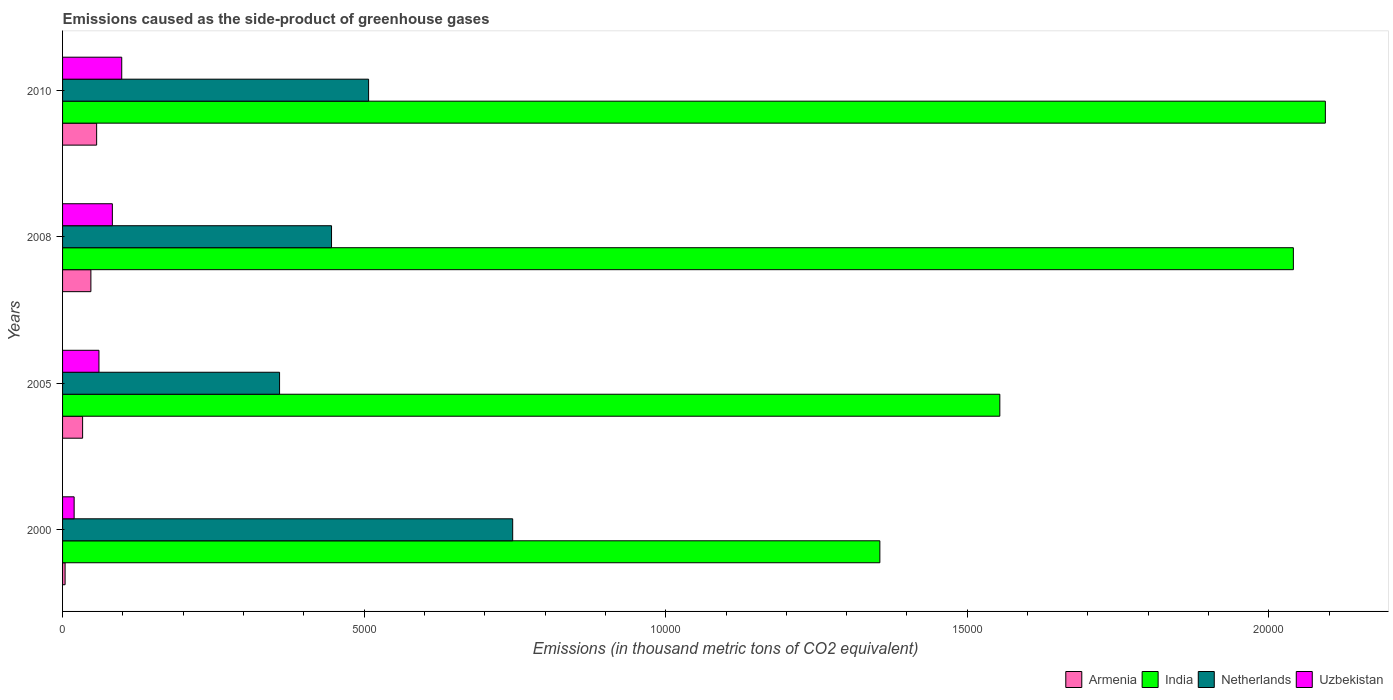How many groups of bars are there?
Make the answer very short. 4. Are the number of bars per tick equal to the number of legend labels?
Provide a short and direct response. Yes. Are the number of bars on each tick of the Y-axis equal?
Your answer should be very brief. Yes. How many bars are there on the 4th tick from the top?
Provide a short and direct response. 4. How many bars are there on the 4th tick from the bottom?
Provide a short and direct response. 4. What is the label of the 4th group of bars from the top?
Provide a short and direct response. 2000. What is the emissions caused as the side-product of greenhouse gases in Uzbekistan in 2000?
Your answer should be very brief. 192. Across all years, what is the maximum emissions caused as the side-product of greenhouse gases in Netherlands?
Your answer should be very brief. 7462.9. Across all years, what is the minimum emissions caused as the side-product of greenhouse gases in Armenia?
Your response must be concise. 42. What is the total emissions caused as the side-product of greenhouse gases in Uzbekistan in the graph?
Provide a succinct answer. 2601.8. What is the difference between the emissions caused as the side-product of greenhouse gases in Armenia in 2008 and that in 2010?
Ensure brevity in your answer.  -95.4. What is the difference between the emissions caused as the side-product of greenhouse gases in India in 2010 and the emissions caused as the side-product of greenhouse gases in Armenia in 2005?
Your answer should be compact. 2.06e+04. What is the average emissions caused as the side-product of greenhouse gases in Netherlands per year?
Make the answer very short. 5148.52. In the year 2010, what is the difference between the emissions caused as the side-product of greenhouse gases in Armenia and emissions caused as the side-product of greenhouse gases in Uzbekistan?
Your answer should be very brief. -416. In how many years, is the emissions caused as the side-product of greenhouse gases in India greater than 1000 thousand metric tons?
Keep it short and to the point. 4. What is the ratio of the emissions caused as the side-product of greenhouse gases in Armenia in 2000 to that in 2008?
Keep it short and to the point. 0.09. Is the emissions caused as the side-product of greenhouse gases in Armenia in 2000 less than that in 2008?
Keep it short and to the point. Yes. What is the difference between the highest and the second highest emissions caused as the side-product of greenhouse gases in Armenia?
Give a very brief answer. 95.4. What is the difference between the highest and the lowest emissions caused as the side-product of greenhouse gases in Netherlands?
Provide a succinct answer. 3865.1. In how many years, is the emissions caused as the side-product of greenhouse gases in Armenia greater than the average emissions caused as the side-product of greenhouse gases in Armenia taken over all years?
Your answer should be compact. 2. Is the sum of the emissions caused as the side-product of greenhouse gases in Netherlands in 2000 and 2010 greater than the maximum emissions caused as the side-product of greenhouse gases in India across all years?
Make the answer very short. No. What does the 1st bar from the bottom in 2000 represents?
Provide a short and direct response. Armenia. How many bars are there?
Ensure brevity in your answer.  16. What is the difference between two consecutive major ticks on the X-axis?
Your answer should be very brief. 5000. Are the values on the major ticks of X-axis written in scientific E-notation?
Provide a succinct answer. No. Does the graph contain any zero values?
Make the answer very short. No. Does the graph contain grids?
Offer a very short reply. No. Where does the legend appear in the graph?
Give a very brief answer. Bottom right. How are the legend labels stacked?
Provide a succinct answer. Horizontal. What is the title of the graph?
Give a very brief answer. Emissions caused as the side-product of greenhouse gases. What is the label or title of the X-axis?
Offer a very short reply. Emissions (in thousand metric tons of CO2 equivalent). What is the label or title of the Y-axis?
Your answer should be very brief. Years. What is the Emissions (in thousand metric tons of CO2 equivalent) of Armenia in 2000?
Keep it short and to the point. 42. What is the Emissions (in thousand metric tons of CO2 equivalent) of India in 2000?
Offer a terse response. 1.36e+04. What is the Emissions (in thousand metric tons of CO2 equivalent) in Netherlands in 2000?
Your answer should be very brief. 7462.9. What is the Emissions (in thousand metric tons of CO2 equivalent) in Uzbekistan in 2000?
Your answer should be very brief. 192. What is the Emissions (in thousand metric tons of CO2 equivalent) in Armenia in 2005?
Ensure brevity in your answer.  332.2. What is the Emissions (in thousand metric tons of CO2 equivalent) of India in 2005?
Offer a terse response. 1.55e+04. What is the Emissions (in thousand metric tons of CO2 equivalent) of Netherlands in 2005?
Your response must be concise. 3597.8. What is the Emissions (in thousand metric tons of CO2 equivalent) of Uzbekistan in 2005?
Your answer should be compact. 603.2. What is the Emissions (in thousand metric tons of CO2 equivalent) of Armenia in 2008?
Give a very brief answer. 469.6. What is the Emissions (in thousand metric tons of CO2 equivalent) of India in 2008?
Give a very brief answer. 2.04e+04. What is the Emissions (in thousand metric tons of CO2 equivalent) in Netherlands in 2008?
Your answer should be compact. 4459.4. What is the Emissions (in thousand metric tons of CO2 equivalent) in Uzbekistan in 2008?
Give a very brief answer. 825.6. What is the Emissions (in thousand metric tons of CO2 equivalent) in Armenia in 2010?
Keep it short and to the point. 565. What is the Emissions (in thousand metric tons of CO2 equivalent) in India in 2010?
Offer a terse response. 2.09e+04. What is the Emissions (in thousand metric tons of CO2 equivalent) in Netherlands in 2010?
Keep it short and to the point. 5074. What is the Emissions (in thousand metric tons of CO2 equivalent) in Uzbekistan in 2010?
Give a very brief answer. 981. Across all years, what is the maximum Emissions (in thousand metric tons of CO2 equivalent) of Armenia?
Your response must be concise. 565. Across all years, what is the maximum Emissions (in thousand metric tons of CO2 equivalent) in India?
Your answer should be very brief. 2.09e+04. Across all years, what is the maximum Emissions (in thousand metric tons of CO2 equivalent) of Netherlands?
Provide a succinct answer. 7462.9. Across all years, what is the maximum Emissions (in thousand metric tons of CO2 equivalent) in Uzbekistan?
Your answer should be compact. 981. Across all years, what is the minimum Emissions (in thousand metric tons of CO2 equivalent) of India?
Ensure brevity in your answer.  1.36e+04. Across all years, what is the minimum Emissions (in thousand metric tons of CO2 equivalent) of Netherlands?
Keep it short and to the point. 3597.8. Across all years, what is the minimum Emissions (in thousand metric tons of CO2 equivalent) in Uzbekistan?
Ensure brevity in your answer.  192. What is the total Emissions (in thousand metric tons of CO2 equivalent) in Armenia in the graph?
Offer a terse response. 1408.8. What is the total Emissions (in thousand metric tons of CO2 equivalent) in India in the graph?
Ensure brevity in your answer.  7.04e+04. What is the total Emissions (in thousand metric tons of CO2 equivalent) in Netherlands in the graph?
Make the answer very short. 2.06e+04. What is the total Emissions (in thousand metric tons of CO2 equivalent) of Uzbekistan in the graph?
Provide a succinct answer. 2601.8. What is the difference between the Emissions (in thousand metric tons of CO2 equivalent) in Armenia in 2000 and that in 2005?
Your response must be concise. -290.2. What is the difference between the Emissions (in thousand metric tons of CO2 equivalent) in India in 2000 and that in 2005?
Your answer should be compact. -1989. What is the difference between the Emissions (in thousand metric tons of CO2 equivalent) of Netherlands in 2000 and that in 2005?
Your response must be concise. 3865.1. What is the difference between the Emissions (in thousand metric tons of CO2 equivalent) in Uzbekistan in 2000 and that in 2005?
Keep it short and to the point. -411.2. What is the difference between the Emissions (in thousand metric tons of CO2 equivalent) in Armenia in 2000 and that in 2008?
Offer a very short reply. -427.6. What is the difference between the Emissions (in thousand metric tons of CO2 equivalent) of India in 2000 and that in 2008?
Offer a very short reply. -6856.2. What is the difference between the Emissions (in thousand metric tons of CO2 equivalent) of Netherlands in 2000 and that in 2008?
Your response must be concise. 3003.5. What is the difference between the Emissions (in thousand metric tons of CO2 equivalent) of Uzbekistan in 2000 and that in 2008?
Your response must be concise. -633.6. What is the difference between the Emissions (in thousand metric tons of CO2 equivalent) in Armenia in 2000 and that in 2010?
Keep it short and to the point. -523. What is the difference between the Emissions (in thousand metric tons of CO2 equivalent) of India in 2000 and that in 2010?
Make the answer very short. -7386.3. What is the difference between the Emissions (in thousand metric tons of CO2 equivalent) of Netherlands in 2000 and that in 2010?
Your response must be concise. 2388.9. What is the difference between the Emissions (in thousand metric tons of CO2 equivalent) of Uzbekistan in 2000 and that in 2010?
Your answer should be compact. -789. What is the difference between the Emissions (in thousand metric tons of CO2 equivalent) of Armenia in 2005 and that in 2008?
Provide a short and direct response. -137.4. What is the difference between the Emissions (in thousand metric tons of CO2 equivalent) in India in 2005 and that in 2008?
Your response must be concise. -4867.2. What is the difference between the Emissions (in thousand metric tons of CO2 equivalent) in Netherlands in 2005 and that in 2008?
Your answer should be very brief. -861.6. What is the difference between the Emissions (in thousand metric tons of CO2 equivalent) in Uzbekistan in 2005 and that in 2008?
Make the answer very short. -222.4. What is the difference between the Emissions (in thousand metric tons of CO2 equivalent) in Armenia in 2005 and that in 2010?
Provide a short and direct response. -232.8. What is the difference between the Emissions (in thousand metric tons of CO2 equivalent) of India in 2005 and that in 2010?
Give a very brief answer. -5397.3. What is the difference between the Emissions (in thousand metric tons of CO2 equivalent) of Netherlands in 2005 and that in 2010?
Provide a short and direct response. -1476.2. What is the difference between the Emissions (in thousand metric tons of CO2 equivalent) of Uzbekistan in 2005 and that in 2010?
Your answer should be compact. -377.8. What is the difference between the Emissions (in thousand metric tons of CO2 equivalent) in Armenia in 2008 and that in 2010?
Provide a short and direct response. -95.4. What is the difference between the Emissions (in thousand metric tons of CO2 equivalent) of India in 2008 and that in 2010?
Your answer should be compact. -530.1. What is the difference between the Emissions (in thousand metric tons of CO2 equivalent) in Netherlands in 2008 and that in 2010?
Give a very brief answer. -614.6. What is the difference between the Emissions (in thousand metric tons of CO2 equivalent) of Uzbekistan in 2008 and that in 2010?
Ensure brevity in your answer.  -155.4. What is the difference between the Emissions (in thousand metric tons of CO2 equivalent) of Armenia in 2000 and the Emissions (in thousand metric tons of CO2 equivalent) of India in 2005?
Ensure brevity in your answer.  -1.55e+04. What is the difference between the Emissions (in thousand metric tons of CO2 equivalent) in Armenia in 2000 and the Emissions (in thousand metric tons of CO2 equivalent) in Netherlands in 2005?
Offer a terse response. -3555.8. What is the difference between the Emissions (in thousand metric tons of CO2 equivalent) in Armenia in 2000 and the Emissions (in thousand metric tons of CO2 equivalent) in Uzbekistan in 2005?
Give a very brief answer. -561.2. What is the difference between the Emissions (in thousand metric tons of CO2 equivalent) in India in 2000 and the Emissions (in thousand metric tons of CO2 equivalent) in Netherlands in 2005?
Your answer should be very brief. 9952.9. What is the difference between the Emissions (in thousand metric tons of CO2 equivalent) in India in 2000 and the Emissions (in thousand metric tons of CO2 equivalent) in Uzbekistan in 2005?
Your answer should be very brief. 1.29e+04. What is the difference between the Emissions (in thousand metric tons of CO2 equivalent) in Netherlands in 2000 and the Emissions (in thousand metric tons of CO2 equivalent) in Uzbekistan in 2005?
Ensure brevity in your answer.  6859.7. What is the difference between the Emissions (in thousand metric tons of CO2 equivalent) in Armenia in 2000 and the Emissions (in thousand metric tons of CO2 equivalent) in India in 2008?
Provide a succinct answer. -2.04e+04. What is the difference between the Emissions (in thousand metric tons of CO2 equivalent) in Armenia in 2000 and the Emissions (in thousand metric tons of CO2 equivalent) in Netherlands in 2008?
Provide a short and direct response. -4417.4. What is the difference between the Emissions (in thousand metric tons of CO2 equivalent) in Armenia in 2000 and the Emissions (in thousand metric tons of CO2 equivalent) in Uzbekistan in 2008?
Give a very brief answer. -783.6. What is the difference between the Emissions (in thousand metric tons of CO2 equivalent) of India in 2000 and the Emissions (in thousand metric tons of CO2 equivalent) of Netherlands in 2008?
Your response must be concise. 9091.3. What is the difference between the Emissions (in thousand metric tons of CO2 equivalent) in India in 2000 and the Emissions (in thousand metric tons of CO2 equivalent) in Uzbekistan in 2008?
Offer a terse response. 1.27e+04. What is the difference between the Emissions (in thousand metric tons of CO2 equivalent) in Netherlands in 2000 and the Emissions (in thousand metric tons of CO2 equivalent) in Uzbekistan in 2008?
Offer a very short reply. 6637.3. What is the difference between the Emissions (in thousand metric tons of CO2 equivalent) of Armenia in 2000 and the Emissions (in thousand metric tons of CO2 equivalent) of India in 2010?
Offer a very short reply. -2.09e+04. What is the difference between the Emissions (in thousand metric tons of CO2 equivalent) in Armenia in 2000 and the Emissions (in thousand metric tons of CO2 equivalent) in Netherlands in 2010?
Your response must be concise. -5032. What is the difference between the Emissions (in thousand metric tons of CO2 equivalent) of Armenia in 2000 and the Emissions (in thousand metric tons of CO2 equivalent) of Uzbekistan in 2010?
Keep it short and to the point. -939. What is the difference between the Emissions (in thousand metric tons of CO2 equivalent) in India in 2000 and the Emissions (in thousand metric tons of CO2 equivalent) in Netherlands in 2010?
Provide a succinct answer. 8476.7. What is the difference between the Emissions (in thousand metric tons of CO2 equivalent) of India in 2000 and the Emissions (in thousand metric tons of CO2 equivalent) of Uzbekistan in 2010?
Ensure brevity in your answer.  1.26e+04. What is the difference between the Emissions (in thousand metric tons of CO2 equivalent) of Netherlands in 2000 and the Emissions (in thousand metric tons of CO2 equivalent) of Uzbekistan in 2010?
Offer a terse response. 6481.9. What is the difference between the Emissions (in thousand metric tons of CO2 equivalent) of Armenia in 2005 and the Emissions (in thousand metric tons of CO2 equivalent) of India in 2008?
Give a very brief answer. -2.01e+04. What is the difference between the Emissions (in thousand metric tons of CO2 equivalent) of Armenia in 2005 and the Emissions (in thousand metric tons of CO2 equivalent) of Netherlands in 2008?
Give a very brief answer. -4127.2. What is the difference between the Emissions (in thousand metric tons of CO2 equivalent) of Armenia in 2005 and the Emissions (in thousand metric tons of CO2 equivalent) of Uzbekistan in 2008?
Provide a succinct answer. -493.4. What is the difference between the Emissions (in thousand metric tons of CO2 equivalent) in India in 2005 and the Emissions (in thousand metric tons of CO2 equivalent) in Netherlands in 2008?
Your answer should be very brief. 1.11e+04. What is the difference between the Emissions (in thousand metric tons of CO2 equivalent) in India in 2005 and the Emissions (in thousand metric tons of CO2 equivalent) in Uzbekistan in 2008?
Keep it short and to the point. 1.47e+04. What is the difference between the Emissions (in thousand metric tons of CO2 equivalent) in Netherlands in 2005 and the Emissions (in thousand metric tons of CO2 equivalent) in Uzbekistan in 2008?
Provide a short and direct response. 2772.2. What is the difference between the Emissions (in thousand metric tons of CO2 equivalent) in Armenia in 2005 and the Emissions (in thousand metric tons of CO2 equivalent) in India in 2010?
Give a very brief answer. -2.06e+04. What is the difference between the Emissions (in thousand metric tons of CO2 equivalent) of Armenia in 2005 and the Emissions (in thousand metric tons of CO2 equivalent) of Netherlands in 2010?
Ensure brevity in your answer.  -4741.8. What is the difference between the Emissions (in thousand metric tons of CO2 equivalent) in Armenia in 2005 and the Emissions (in thousand metric tons of CO2 equivalent) in Uzbekistan in 2010?
Keep it short and to the point. -648.8. What is the difference between the Emissions (in thousand metric tons of CO2 equivalent) in India in 2005 and the Emissions (in thousand metric tons of CO2 equivalent) in Netherlands in 2010?
Provide a succinct answer. 1.05e+04. What is the difference between the Emissions (in thousand metric tons of CO2 equivalent) in India in 2005 and the Emissions (in thousand metric tons of CO2 equivalent) in Uzbekistan in 2010?
Provide a succinct answer. 1.46e+04. What is the difference between the Emissions (in thousand metric tons of CO2 equivalent) in Netherlands in 2005 and the Emissions (in thousand metric tons of CO2 equivalent) in Uzbekistan in 2010?
Provide a succinct answer. 2616.8. What is the difference between the Emissions (in thousand metric tons of CO2 equivalent) in Armenia in 2008 and the Emissions (in thousand metric tons of CO2 equivalent) in India in 2010?
Provide a short and direct response. -2.05e+04. What is the difference between the Emissions (in thousand metric tons of CO2 equivalent) of Armenia in 2008 and the Emissions (in thousand metric tons of CO2 equivalent) of Netherlands in 2010?
Ensure brevity in your answer.  -4604.4. What is the difference between the Emissions (in thousand metric tons of CO2 equivalent) in Armenia in 2008 and the Emissions (in thousand metric tons of CO2 equivalent) in Uzbekistan in 2010?
Offer a terse response. -511.4. What is the difference between the Emissions (in thousand metric tons of CO2 equivalent) in India in 2008 and the Emissions (in thousand metric tons of CO2 equivalent) in Netherlands in 2010?
Your response must be concise. 1.53e+04. What is the difference between the Emissions (in thousand metric tons of CO2 equivalent) in India in 2008 and the Emissions (in thousand metric tons of CO2 equivalent) in Uzbekistan in 2010?
Make the answer very short. 1.94e+04. What is the difference between the Emissions (in thousand metric tons of CO2 equivalent) of Netherlands in 2008 and the Emissions (in thousand metric tons of CO2 equivalent) of Uzbekistan in 2010?
Provide a succinct answer. 3478.4. What is the average Emissions (in thousand metric tons of CO2 equivalent) in Armenia per year?
Make the answer very short. 352.2. What is the average Emissions (in thousand metric tons of CO2 equivalent) in India per year?
Your response must be concise. 1.76e+04. What is the average Emissions (in thousand metric tons of CO2 equivalent) in Netherlands per year?
Keep it short and to the point. 5148.52. What is the average Emissions (in thousand metric tons of CO2 equivalent) of Uzbekistan per year?
Your answer should be compact. 650.45. In the year 2000, what is the difference between the Emissions (in thousand metric tons of CO2 equivalent) in Armenia and Emissions (in thousand metric tons of CO2 equivalent) in India?
Give a very brief answer. -1.35e+04. In the year 2000, what is the difference between the Emissions (in thousand metric tons of CO2 equivalent) of Armenia and Emissions (in thousand metric tons of CO2 equivalent) of Netherlands?
Your answer should be compact. -7420.9. In the year 2000, what is the difference between the Emissions (in thousand metric tons of CO2 equivalent) of Armenia and Emissions (in thousand metric tons of CO2 equivalent) of Uzbekistan?
Offer a terse response. -150. In the year 2000, what is the difference between the Emissions (in thousand metric tons of CO2 equivalent) in India and Emissions (in thousand metric tons of CO2 equivalent) in Netherlands?
Your response must be concise. 6087.8. In the year 2000, what is the difference between the Emissions (in thousand metric tons of CO2 equivalent) in India and Emissions (in thousand metric tons of CO2 equivalent) in Uzbekistan?
Offer a very short reply. 1.34e+04. In the year 2000, what is the difference between the Emissions (in thousand metric tons of CO2 equivalent) in Netherlands and Emissions (in thousand metric tons of CO2 equivalent) in Uzbekistan?
Provide a succinct answer. 7270.9. In the year 2005, what is the difference between the Emissions (in thousand metric tons of CO2 equivalent) in Armenia and Emissions (in thousand metric tons of CO2 equivalent) in India?
Make the answer very short. -1.52e+04. In the year 2005, what is the difference between the Emissions (in thousand metric tons of CO2 equivalent) of Armenia and Emissions (in thousand metric tons of CO2 equivalent) of Netherlands?
Keep it short and to the point. -3265.6. In the year 2005, what is the difference between the Emissions (in thousand metric tons of CO2 equivalent) in Armenia and Emissions (in thousand metric tons of CO2 equivalent) in Uzbekistan?
Offer a very short reply. -271. In the year 2005, what is the difference between the Emissions (in thousand metric tons of CO2 equivalent) of India and Emissions (in thousand metric tons of CO2 equivalent) of Netherlands?
Ensure brevity in your answer.  1.19e+04. In the year 2005, what is the difference between the Emissions (in thousand metric tons of CO2 equivalent) in India and Emissions (in thousand metric tons of CO2 equivalent) in Uzbekistan?
Your answer should be compact. 1.49e+04. In the year 2005, what is the difference between the Emissions (in thousand metric tons of CO2 equivalent) of Netherlands and Emissions (in thousand metric tons of CO2 equivalent) of Uzbekistan?
Offer a terse response. 2994.6. In the year 2008, what is the difference between the Emissions (in thousand metric tons of CO2 equivalent) of Armenia and Emissions (in thousand metric tons of CO2 equivalent) of India?
Offer a very short reply. -1.99e+04. In the year 2008, what is the difference between the Emissions (in thousand metric tons of CO2 equivalent) of Armenia and Emissions (in thousand metric tons of CO2 equivalent) of Netherlands?
Your response must be concise. -3989.8. In the year 2008, what is the difference between the Emissions (in thousand metric tons of CO2 equivalent) of Armenia and Emissions (in thousand metric tons of CO2 equivalent) of Uzbekistan?
Ensure brevity in your answer.  -356. In the year 2008, what is the difference between the Emissions (in thousand metric tons of CO2 equivalent) of India and Emissions (in thousand metric tons of CO2 equivalent) of Netherlands?
Keep it short and to the point. 1.59e+04. In the year 2008, what is the difference between the Emissions (in thousand metric tons of CO2 equivalent) in India and Emissions (in thousand metric tons of CO2 equivalent) in Uzbekistan?
Provide a short and direct response. 1.96e+04. In the year 2008, what is the difference between the Emissions (in thousand metric tons of CO2 equivalent) of Netherlands and Emissions (in thousand metric tons of CO2 equivalent) of Uzbekistan?
Ensure brevity in your answer.  3633.8. In the year 2010, what is the difference between the Emissions (in thousand metric tons of CO2 equivalent) in Armenia and Emissions (in thousand metric tons of CO2 equivalent) in India?
Make the answer very short. -2.04e+04. In the year 2010, what is the difference between the Emissions (in thousand metric tons of CO2 equivalent) of Armenia and Emissions (in thousand metric tons of CO2 equivalent) of Netherlands?
Provide a succinct answer. -4509. In the year 2010, what is the difference between the Emissions (in thousand metric tons of CO2 equivalent) of Armenia and Emissions (in thousand metric tons of CO2 equivalent) of Uzbekistan?
Offer a terse response. -416. In the year 2010, what is the difference between the Emissions (in thousand metric tons of CO2 equivalent) in India and Emissions (in thousand metric tons of CO2 equivalent) in Netherlands?
Make the answer very short. 1.59e+04. In the year 2010, what is the difference between the Emissions (in thousand metric tons of CO2 equivalent) in India and Emissions (in thousand metric tons of CO2 equivalent) in Uzbekistan?
Your response must be concise. 2.00e+04. In the year 2010, what is the difference between the Emissions (in thousand metric tons of CO2 equivalent) in Netherlands and Emissions (in thousand metric tons of CO2 equivalent) in Uzbekistan?
Give a very brief answer. 4093. What is the ratio of the Emissions (in thousand metric tons of CO2 equivalent) in Armenia in 2000 to that in 2005?
Your answer should be very brief. 0.13. What is the ratio of the Emissions (in thousand metric tons of CO2 equivalent) of India in 2000 to that in 2005?
Provide a short and direct response. 0.87. What is the ratio of the Emissions (in thousand metric tons of CO2 equivalent) of Netherlands in 2000 to that in 2005?
Your answer should be compact. 2.07. What is the ratio of the Emissions (in thousand metric tons of CO2 equivalent) of Uzbekistan in 2000 to that in 2005?
Your answer should be very brief. 0.32. What is the ratio of the Emissions (in thousand metric tons of CO2 equivalent) in Armenia in 2000 to that in 2008?
Offer a very short reply. 0.09. What is the ratio of the Emissions (in thousand metric tons of CO2 equivalent) in India in 2000 to that in 2008?
Give a very brief answer. 0.66. What is the ratio of the Emissions (in thousand metric tons of CO2 equivalent) of Netherlands in 2000 to that in 2008?
Offer a terse response. 1.67. What is the ratio of the Emissions (in thousand metric tons of CO2 equivalent) of Uzbekistan in 2000 to that in 2008?
Offer a very short reply. 0.23. What is the ratio of the Emissions (in thousand metric tons of CO2 equivalent) of Armenia in 2000 to that in 2010?
Provide a short and direct response. 0.07. What is the ratio of the Emissions (in thousand metric tons of CO2 equivalent) of India in 2000 to that in 2010?
Ensure brevity in your answer.  0.65. What is the ratio of the Emissions (in thousand metric tons of CO2 equivalent) in Netherlands in 2000 to that in 2010?
Keep it short and to the point. 1.47. What is the ratio of the Emissions (in thousand metric tons of CO2 equivalent) in Uzbekistan in 2000 to that in 2010?
Keep it short and to the point. 0.2. What is the ratio of the Emissions (in thousand metric tons of CO2 equivalent) in Armenia in 2005 to that in 2008?
Provide a short and direct response. 0.71. What is the ratio of the Emissions (in thousand metric tons of CO2 equivalent) of India in 2005 to that in 2008?
Ensure brevity in your answer.  0.76. What is the ratio of the Emissions (in thousand metric tons of CO2 equivalent) in Netherlands in 2005 to that in 2008?
Provide a short and direct response. 0.81. What is the ratio of the Emissions (in thousand metric tons of CO2 equivalent) in Uzbekistan in 2005 to that in 2008?
Provide a short and direct response. 0.73. What is the ratio of the Emissions (in thousand metric tons of CO2 equivalent) in Armenia in 2005 to that in 2010?
Give a very brief answer. 0.59. What is the ratio of the Emissions (in thousand metric tons of CO2 equivalent) of India in 2005 to that in 2010?
Keep it short and to the point. 0.74. What is the ratio of the Emissions (in thousand metric tons of CO2 equivalent) in Netherlands in 2005 to that in 2010?
Provide a short and direct response. 0.71. What is the ratio of the Emissions (in thousand metric tons of CO2 equivalent) in Uzbekistan in 2005 to that in 2010?
Offer a very short reply. 0.61. What is the ratio of the Emissions (in thousand metric tons of CO2 equivalent) in Armenia in 2008 to that in 2010?
Ensure brevity in your answer.  0.83. What is the ratio of the Emissions (in thousand metric tons of CO2 equivalent) of India in 2008 to that in 2010?
Provide a succinct answer. 0.97. What is the ratio of the Emissions (in thousand metric tons of CO2 equivalent) of Netherlands in 2008 to that in 2010?
Provide a succinct answer. 0.88. What is the ratio of the Emissions (in thousand metric tons of CO2 equivalent) in Uzbekistan in 2008 to that in 2010?
Ensure brevity in your answer.  0.84. What is the difference between the highest and the second highest Emissions (in thousand metric tons of CO2 equivalent) in Armenia?
Your answer should be compact. 95.4. What is the difference between the highest and the second highest Emissions (in thousand metric tons of CO2 equivalent) in India?
Your response must be concise. 530.1. What is the difference between the highest and the second highest Emissions (in thousand metric tons of CO2 equivalent) in Netherlands?
Provide a short and direct response. 2388.9. What is the difference between the highest and the second highest Emissions (in thousand metric tons of CO2 equivalent) of Uzbekistan?
Your answer should be very brief. 155.4. What is the difference between the highest and the lowest Emissions (in thousand metric tons of CO2 equivalent) of Armenia?
Offer a terse response. 523. What is the difference between the highest and the lowest Emissions (in thousand metric tons of CO2 equivalent) of India?
Provide a short and direct response. 7386.3. What is the difference between the highest and the lowest Emissions (in thousand metric tons of CO2 equivalent) of Netherlands?
Offer a very short reply. 3865.1. What is the difference between the highest and the lowest Emissions (in thousand metric tons of CO2 equivalent) in Uzbekistan?
Ensure brevity in your answer.  789. 